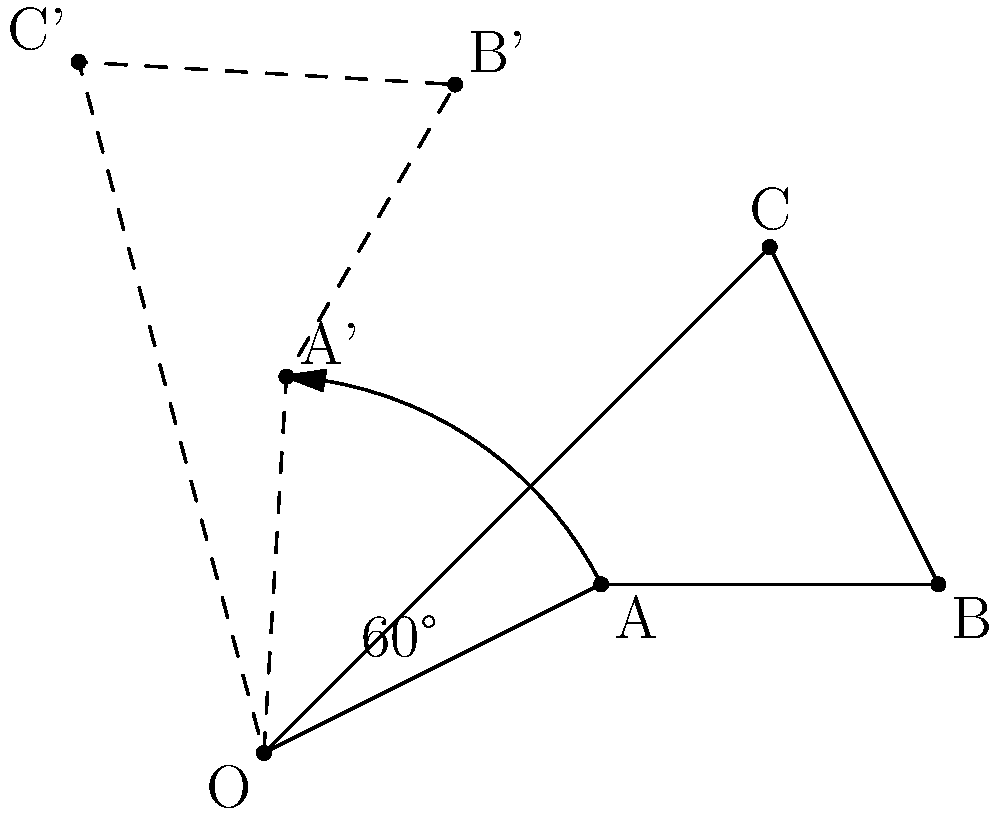Given a triangle ABC with vertices $A(2,1)$, $B(4,1)$, and $C(3,3)$, rotate it 60° counterclockwise around the origin $O(0,0)$. What are the coordinates of vertex $C'$ after the rotation? To find the coordinates of $C'$ after rotating triangle ABC by 60° counterclockwise around the origin, we can use the rotation matrix:

$$R = \begin{bmatrix} \cos\theta & -\sin\theta \\ \sin\theta & \cos\theta \end{bmatrix}$$

Where $\theta = 60° = \frac{\pi}{3}$ radians.

Steps:
1) Calculate $\cos 60°$ and $\sin 60°$:
   $\cos 60° = \frac{1}{2}$
   $\sin 60° = \frac{\sqrt{3}}{2}$

2) Construct the rotation matrix:
   $$R = \begin{bmatrix} \frac{1}{2} & -\frac{\sqrt{3}}{2} \\ \frac{\sqrt{3}}{2} & \frac{1}{2} \end{bmatrix}$$

3) Multiply the rotation matrix by the coordinates of C(3,3):
   $$\begin{bmatrix} \frac{1}{2} & -\frac{\sqrt{3}}{2} \\ \frac{\sqrt{3}}{2} & \frac{1}{2} \end{bmatrix} \begin{bmatrix} 3 \\ 3 \end{bmatrix} = \begin{bmatrix} \frac{1}{2}(3) - \frac{\sqrt{3}}{2}(3) \\ \frac{\sqrt{3}}{2}(3) + \frac{1}{2}(3) \end{bmatrix}$$

4) Simplify:
   $$\begin{bmatrix} \frac{3}{2} - \frac{3\sqrt{3}}{2} \\ \frac{3\sqrt{3}}{2} + \frac{3}{2} \end{bmatrix} = \begin{bmatrix} -\frac{3\sqrt{3}-3}{2} \\ \frac{3\sqrt{3}+3}{2} \end{bmatrix}$$

Therefore, the coordinates of $C'$ after rotation are $(-\frac{3\sqrt{3}-3}{2}, \frac{3\sqrt{3}+3}{2})$.
Answer: $C'(-\frac{3\sqrt{3}-3}{2}, \frac{3\sqrt{3}+3}{2})$ 